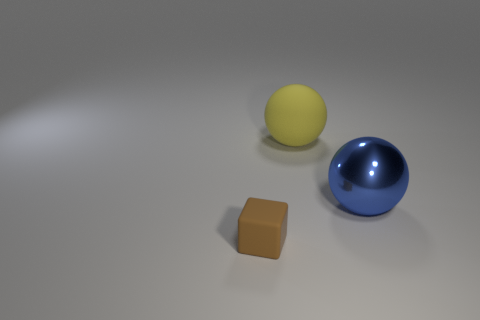Add 2 brown objects. How many objects exist? 5 Subtract all balls. How many objects are left? 1 Subtract 1 blue spheres. How many objects are left? 2 Subtract all spheres. Subtract all brown rubber cubes. How many objects are left? 0 Add 2 blue spheres. How many blue spheres are left? 3 Add 1 tiny gray cylinders. How many tiny gray cylinders exist? 1 